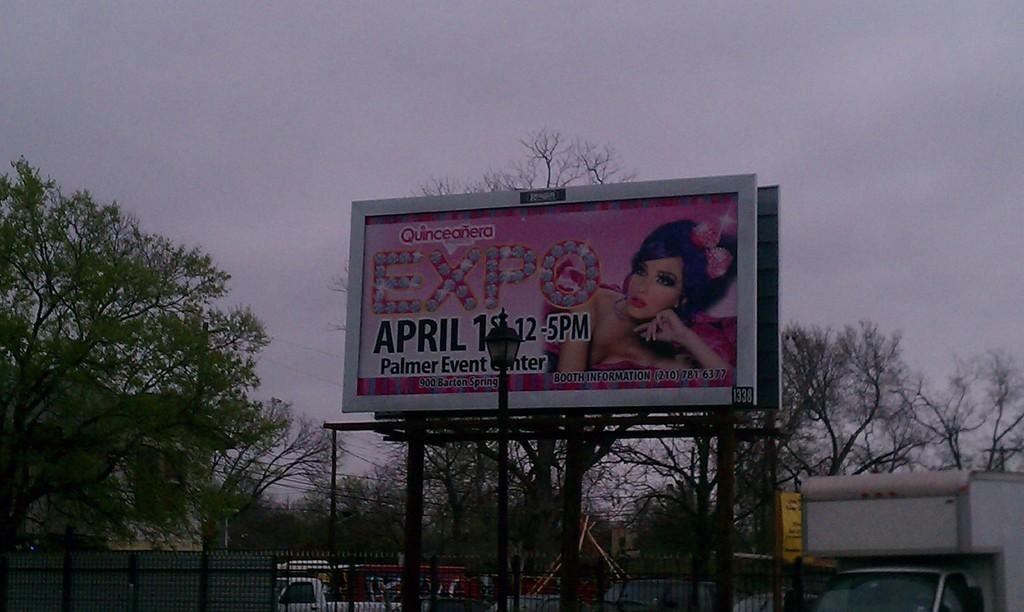<image>
Write a terse but informative summary of the picture. A billboard for an Expo on April 1 featuring a woman with a pink bow. 